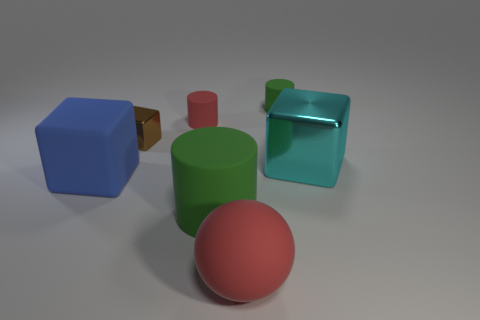Are there any other things that are the same color as the rubber cube?
Provide a succinct answer. No. Is the color of the large rubber cylinder the same as the cylinder to the right of the large ball?
Your answer should be compact. Yes. There is a small rubber cylinder that is left of the green object behind the shiny block in front of the tiny brown metallic cube; what color is it?
Offer a very short reply. Red. Is there another yellow object of the same shape as the tiny metallic thing?
Give a very brief answer. No. There is a matte sphere that is the same size as the blue matte cube; what is its color?
Offer a very short reply. Red. What material is the red object that is in front of the big cyan shiny thing?
Provide a short and direct response. Rubber. There is a green matte thing behind the big cyan metal object; is its shape the same as the green rubber thing that is left of the large ball?
Keep it short and to the point. Yes. Is the number of small green rubber things that are left of the red rubber cylinder the same as the number of blue rubber cylinders?
Ensure brevity in your answer.  Yes. What number of tiny red cylinders have the same material as the big blue block?
Your answer should be compact. 1. What color is the big cylinder that is the same material as the big blue object?
Your answer should be compact. Green. 